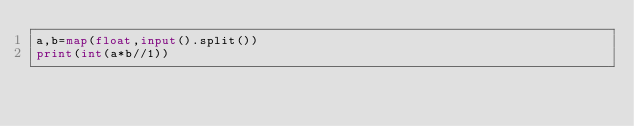Convert code to text. <code><loc_0><loc_0><loc_500><loc_500><_Python_>a,b=map(float,input().split())
print(int(a*b//1))</code> 